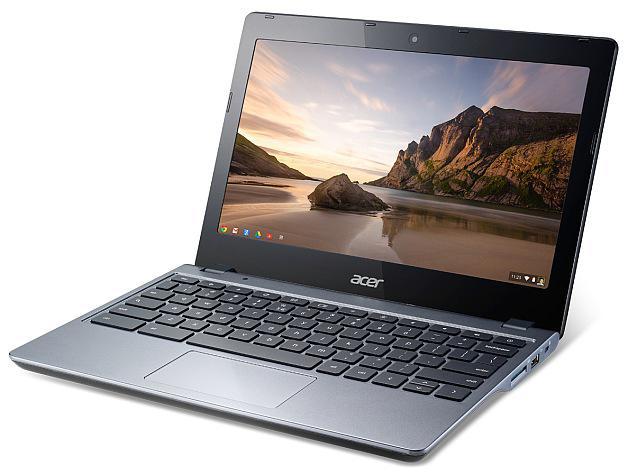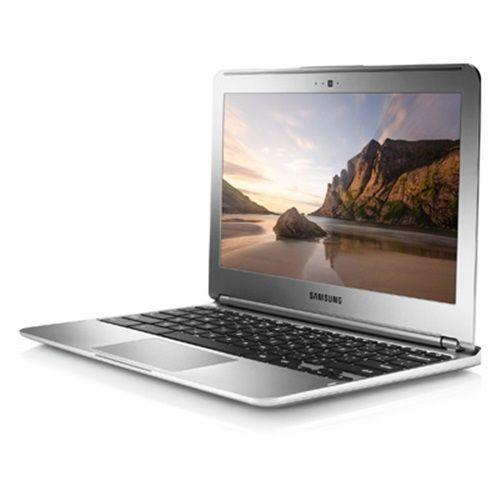The first image is the image on the left, the second image is the image on the right. Assess this claim about the two images: "In at least one image there is a laptop facing front right with a white box on the screen.". Correct or not? Answer yes or no. No. The first image is the image on the left, the second image is the image on the right. Evaluate the accuracy of this statement regarding the images: "Each image shows one laptop open to at least 90-degrees and displaying a landscape with sky, and the laptops on the left and right face the same general direction.". Is it true? Answer yes or no. Yes. 